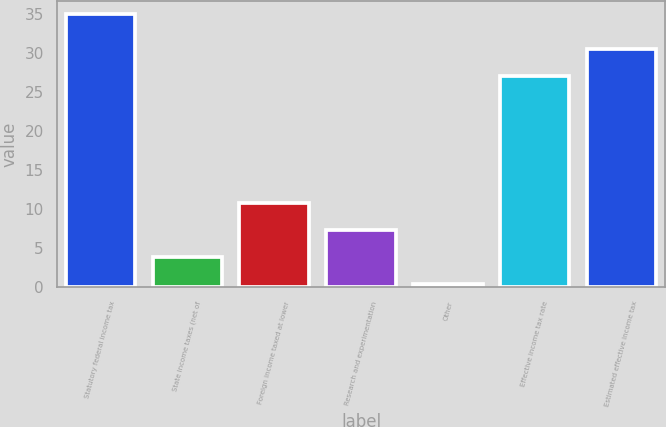Convert chart. <chart><loc_0><loc_0><loc_500><loc_500><bar_chart><fcel>Statutory federal income tax<fcel>State income taxes (net of<fcel>Foreign income taxed at lower<fcel>Research and experimentation<fcel>Other<fcel>Effective income tax rate<fcel>Estimated effective income tax<nl><fcel>35<fcel>3.95<fcel>10.85<fcel>7.4<fcel>0.5<fcel>27.1<fcel>30.55<nl></chart> 